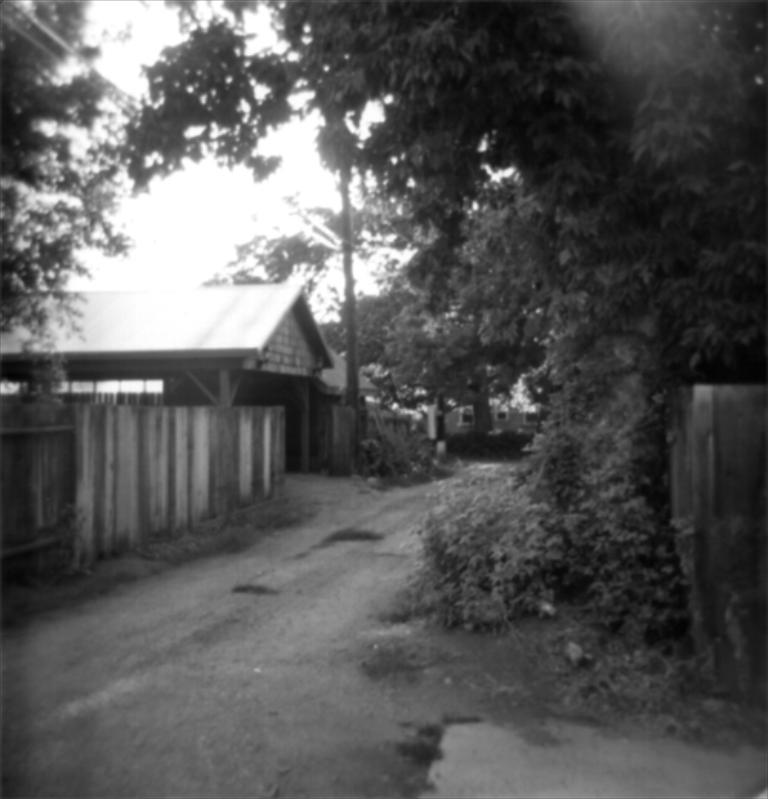What is the color scheme of the image? The image is black and white. What can be seen in the center of the image? There is a sky in the center of the image. What type of natural elements are present in the image? There are trees and plants in the image. What type of man-made structures can be seen in the image? There are buildings and a fence in the image. What type of infrastructure is visible in the image? There are wires and a road in the image. Are there any other objects or features in the image? Yes, there are a few other objects in the image. How many stockings are hanging from the trees in the image? There are no stockings hanging from the trees in the image. What type of vein is visible in the image? There are no veins visible in the image. 